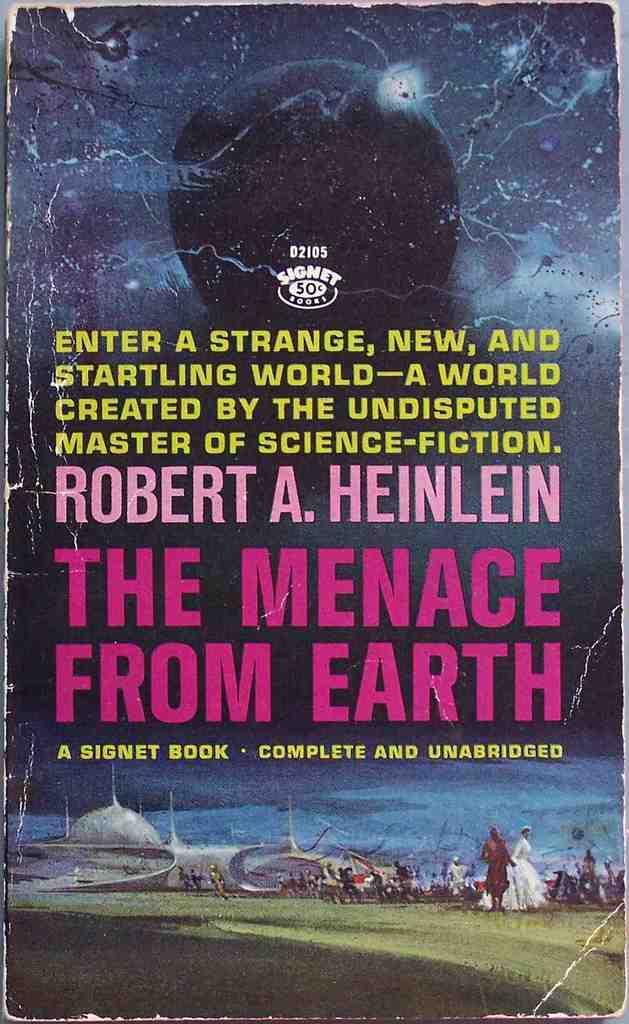<image>
Share a concise interpretation of the image provided. Dogeared paperback book by Robert A Heinlein "The Menace From Earth." 